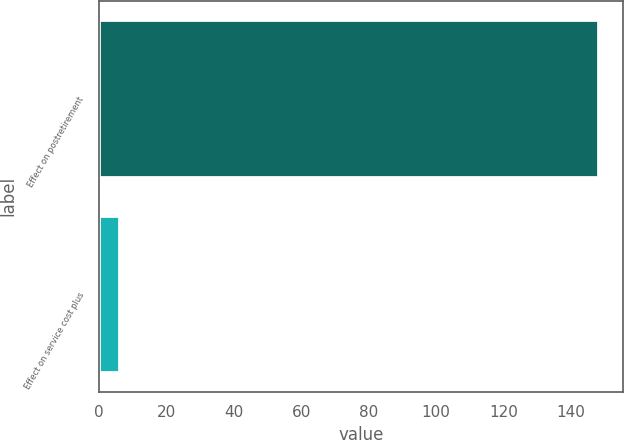Convert chart to OTSL. <chart><loc_0><loc_0><loc_500><loc_500><bar_chart><fcel>Effect on postretirement<fcel>Effect on service cost plus<nl><fcel>148<fcel>6<nl></chart> 